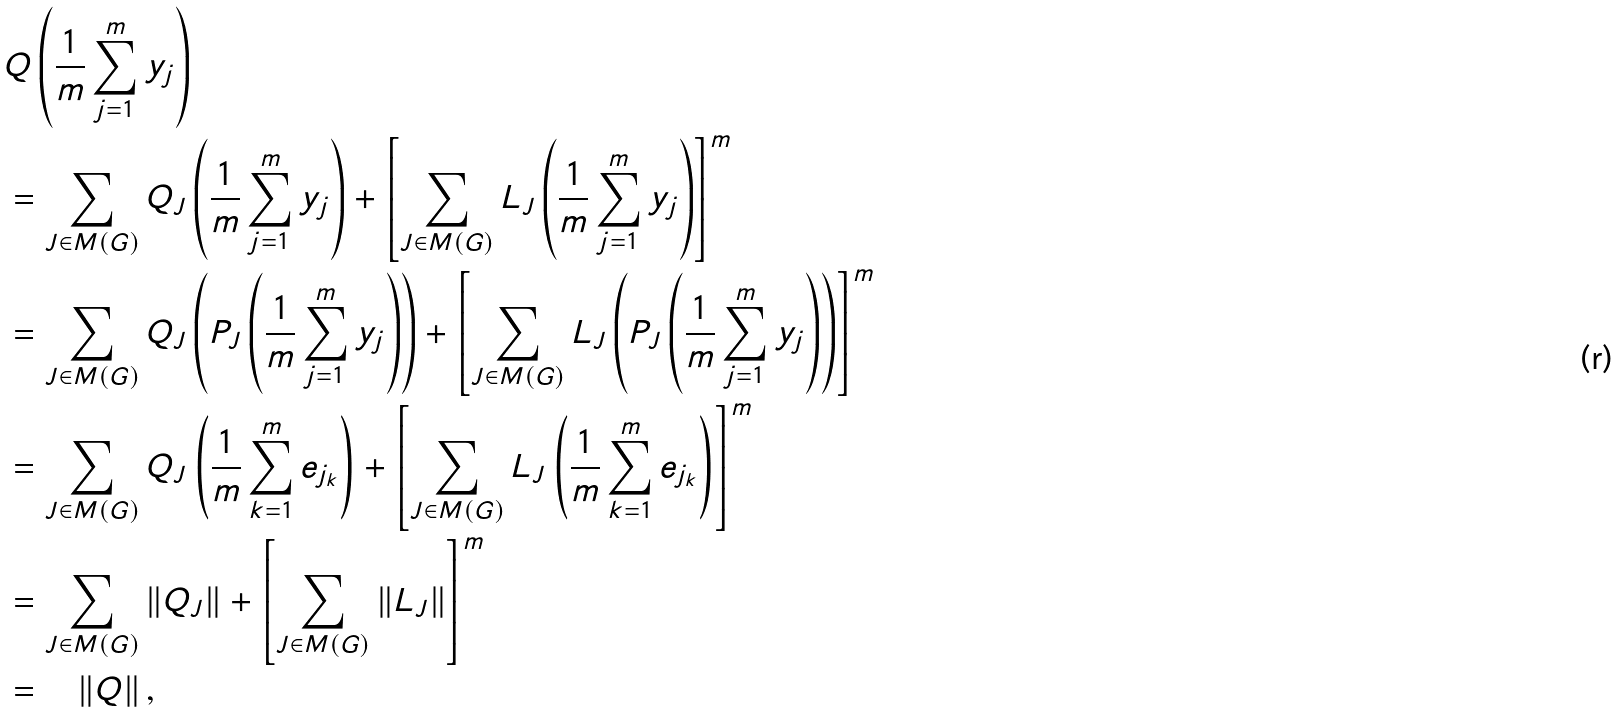Convert formula to latex. <formula><loc_0><loc_0><loc_500><loc_500>& Q \left ( \frac { 1 } { m } \sum ^ { m } _ { j = 1 } y _ { j } \right ) \\ & = \sum _ { J \in M ( G ) } Q _ { J } \left ( \frac { 1 } { m } \sum ^ { m } _ { j = 1 } y _ { j } \right ) + \left [ \sum _ { J \in M ( G ) } L _ { J } \left ( \frac { 1 } { m } \sum ^ { m } _ { j = 1 } y _ { j } \right ) \right ] ^ { m } \\ & = \sum _ { J \in M ( G ) } Q _ { J } \left ( P _ { J } \left ( \frac { 1 } { m } \sum ^ { m } _ { j = 1 } y _ { j } \right ) \right ) + \left [ \sum _ { J \in M ( G ) } L _ { J } \left ( P _ { J } \left ( \frac { 1 } { m } \sum ^ { m } _ { j = 1 } y _ { j } \right ) \right ) \right ] ^ { m } \\ & = \sum _ { J \in M ( G ) } Q _ { J } \left ( \frac { 1 } { m } \sum ^ { m } _ { k = 1 } e _ { j _ { k } } \right ) + \left [ \sum _ { J \in M ( G ) } L _ { J } \left ( \frac { 1 } { m } \sum ^ { m } _ { k = 1 } e _ { j _ { k } } \right ) \right ] ^ { m } \\ & = \sum _ { J \in M ( G ) } \| Q _ { J } \| + \left [ \sum _ { J \in M ( G ) } \| L _ { J } \| \right ] ^ { m } \\ & = \quad \left \| Q \right \| ,</formula> 